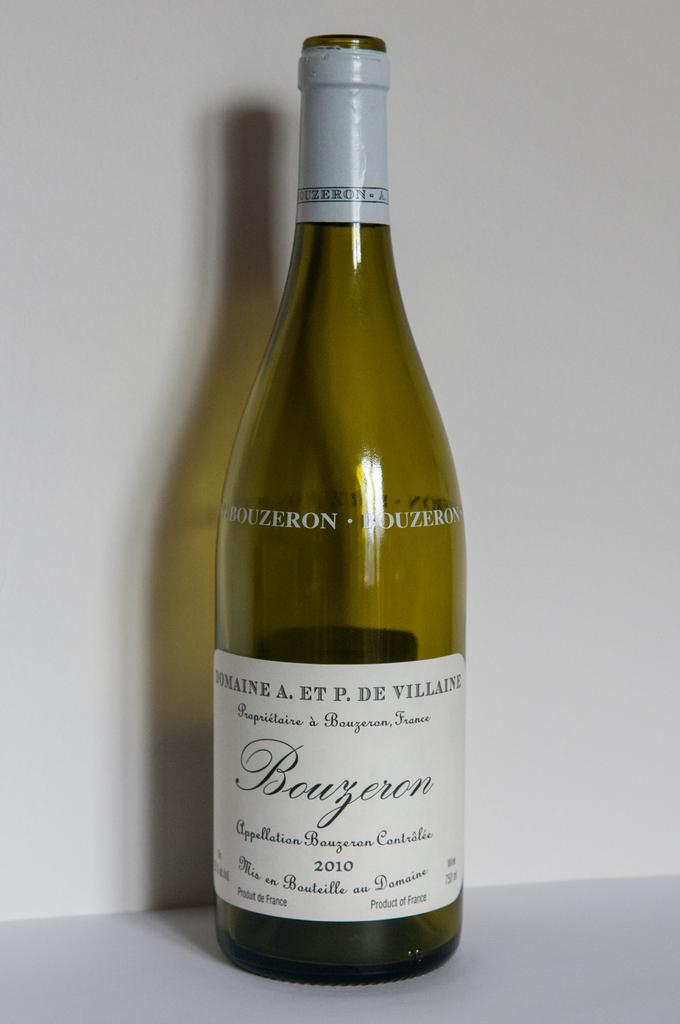<image>
Relay a brief, clear account of the picture shown. A bottle of 2010 Bouzeron sits against a white background. 